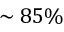<formula> <loc_0><loc_0><loc_500><loc_500>\sim 8 5 \%</formula> 